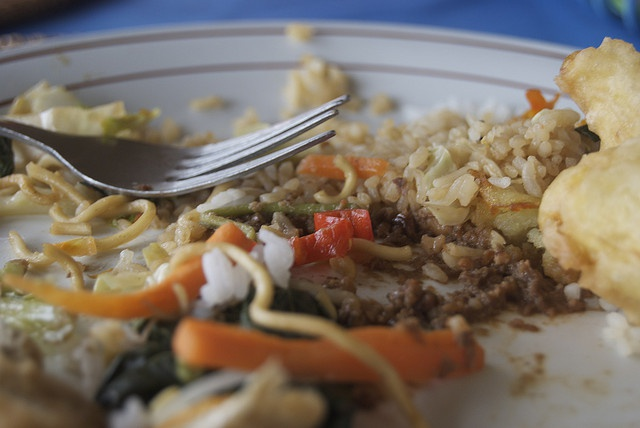Describe the objects in this image and their specific colors. I can see dining table in black, blue, navy, and darkblue tones, carrot in black, maroon, and brown tones, fork in black, darkgray, and gray tones, carrot in black, brown, tan, gray, and maroon tones, and carrot in black, brown, gray, and tan tones in this image. 